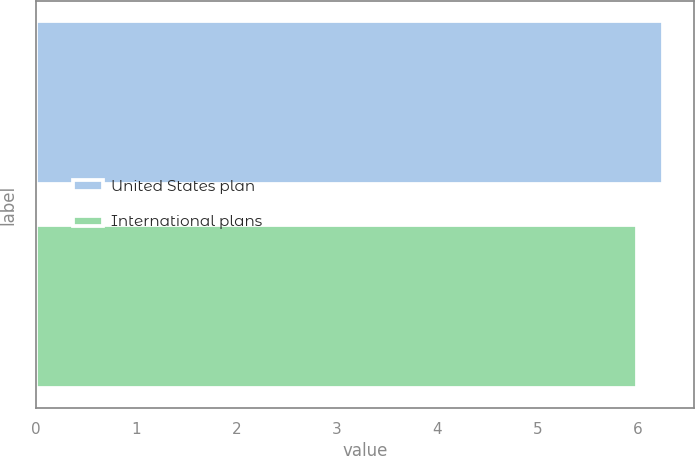<chart> <loc_0><loc_0><loc_500><loc_500><bar_chart><fcel>United States plan<fcel>International plans<nl><fcel>6.25<fcel>6<nl></chart> 